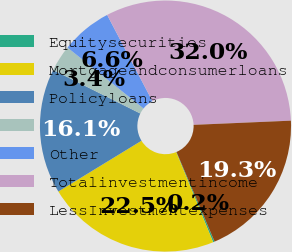Convert chart to OTSL. <chart><loc_0><loc_0><loc_500><loc_500><pie_chart><fcel>Equitysecurities<fcel>Mortgageandconsumerloans<fcel>Policyloans<fcel>Unnamed: 3<fcel>Other<fcel>Totalinvestmentincome<fcel>LessInvestmentexpenses<nl><fcel>0.2%<fcel>22.47%<fcel>16.1%<fcel>3.38%<fcel>6.56%<fcel>32.01%<fcel>19.29%<nl></chart> 